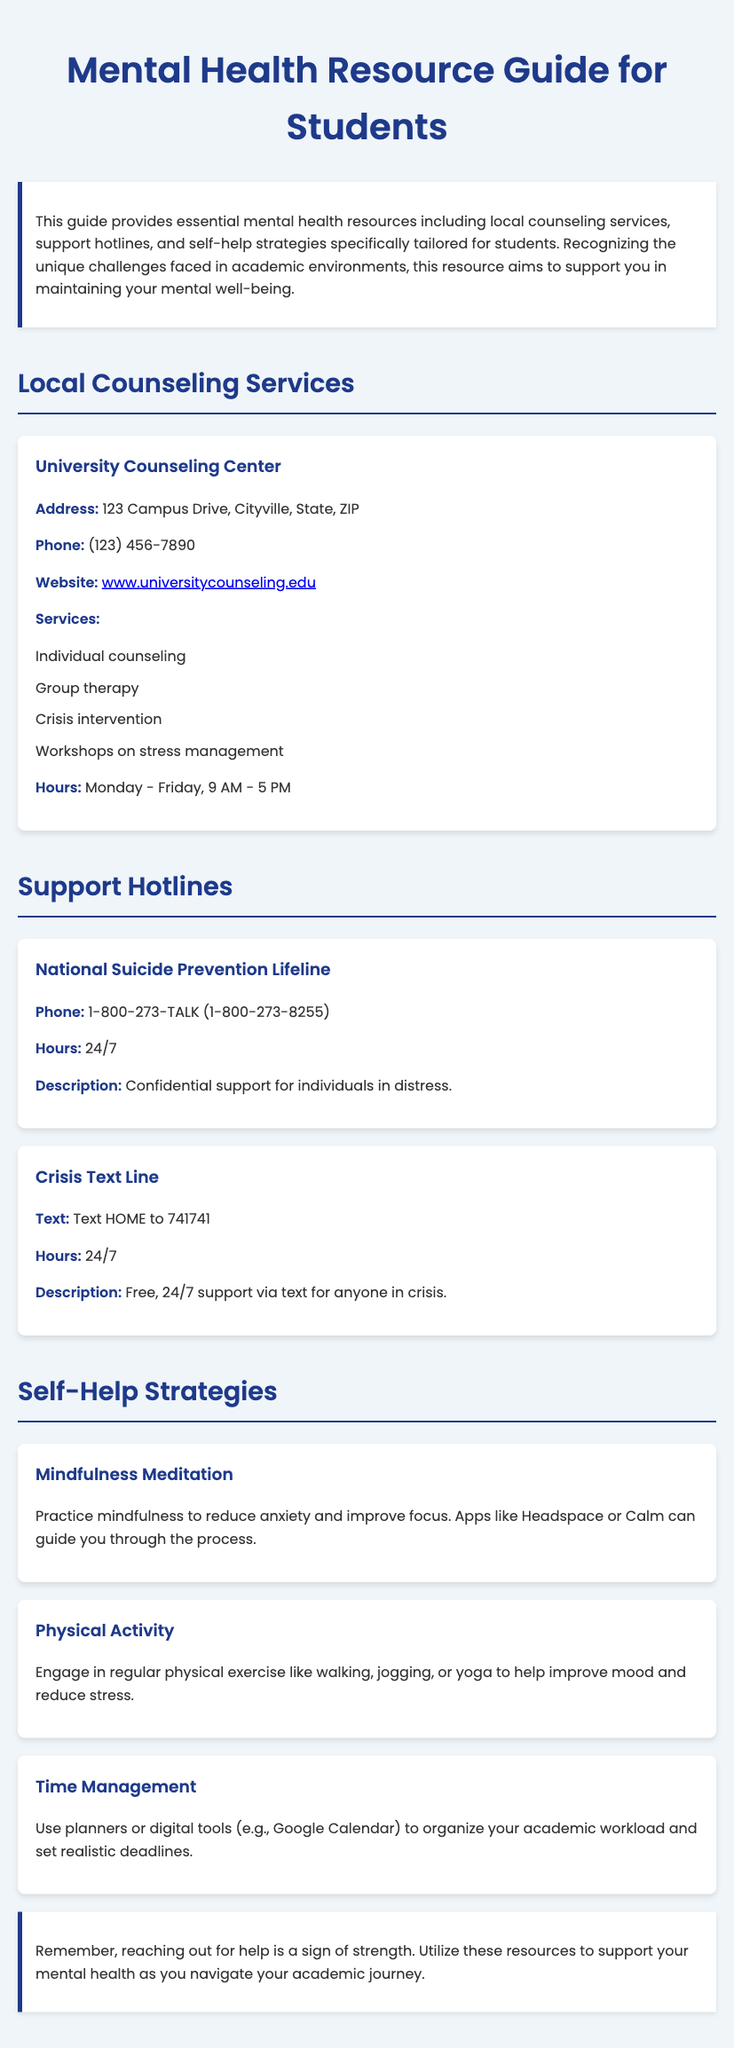What is the address of the University Counseling Center? The address of the University Counseling Center is listed in the document, specifically under the Local Counseling Services section.
Answer: 123 Campus Drive, Cityville, State, ZIP What is the phone number for the National Suicide Prevention Lifeline? The phone number can be found in the Support Hotlines section, specifically for the National Suicide Prevention Lifeline.
Answer: 1-800-273-TALK (1-800-273-8255) What services are offered at the University Counseling Center? The services offered at the University Counseling Center are detailed in a list under the Local Counseling Services section.
Answer: Individual counseling, Group therapy, Crisis intervention, Workshops on stress management Which app is suggested for mindfulness practice? The document mentions specific apps for mindfulness practice under the Self-Help Strategies section, indicating recommendations for students.
Answer: Headspace or Calm How many self-help strategies are listed in the document? The number of self-help strategies can be found by counting the individual strategies outlined in the Self-Help Strategies section of the document.
Answer: 3 What hours is the University Counseling Center open? The hours of operation for the University Counseling Center are stated in the Local Counseling Services section and provide specific opening times.
Answer: Monday - Friday, 9 AM - 5 PM What is the purpose of this mental health resource guide? The purpose of the guide is mentioned in the introduction and provides insight into its intended use for students.
Answer: Support mental well-being What is the main type of support offered by the Crisis Text Line? The type of support offered by the Crisis Text Line is described in the Support Hotlines section, under its description.
Answer: Free, 24/7 support via text 